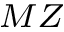<formula> <loc_0><loc_0><loc_500><loc_500>_ { M Z }</formula> 